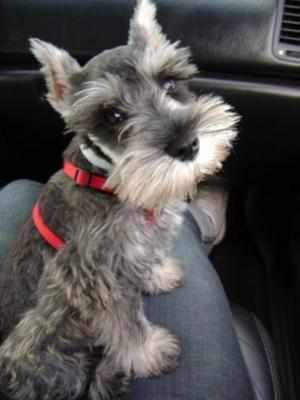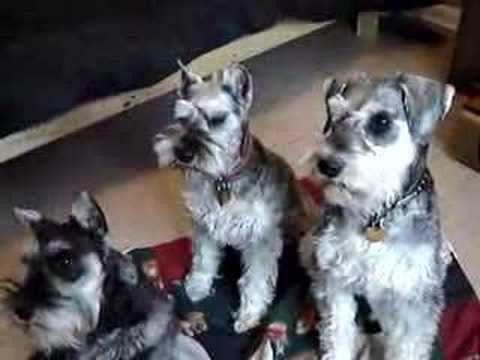The first image is the image on the left, the second image is the image on the right. Given the left and right images, does the statement "An image shows at least one schnauzer dog wearing something bright red." hold true? Answer yes or no. Yes. The first image is the image on the left, the second image is the image on the right. For the images displayed, is the sentence "One dog has a red collar in the image on the left." factually correct? Answer yes or no. Yes. 